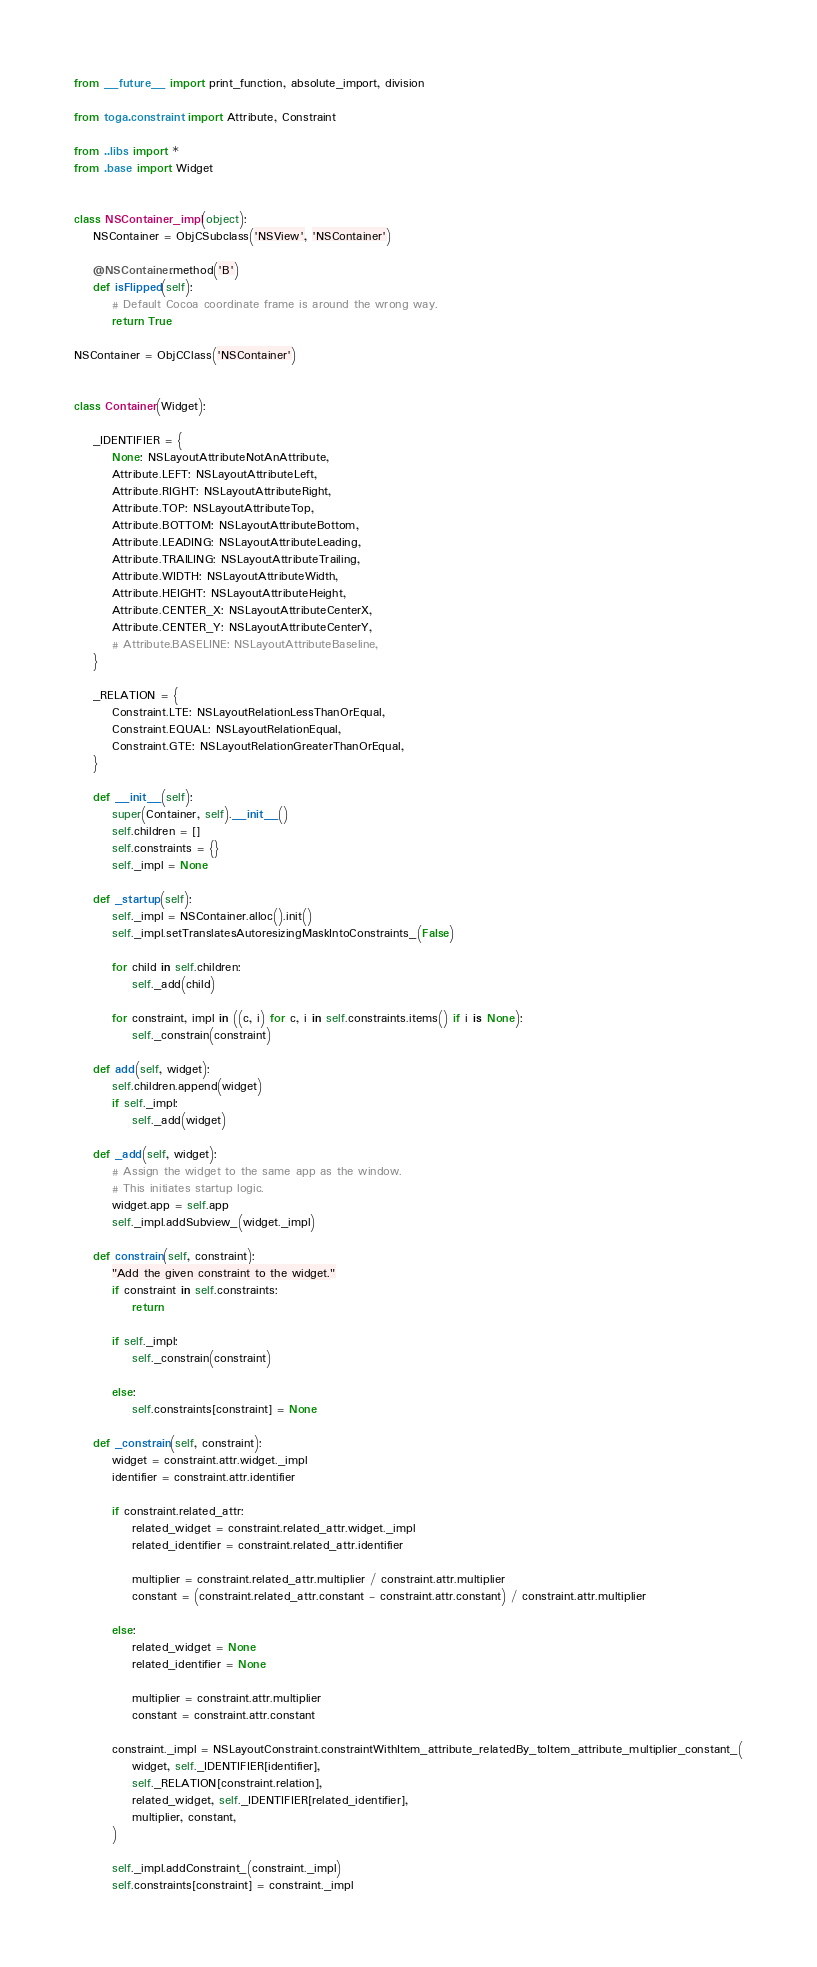Convert code to text. <code><loc_0><loc_0><loc_500><loc_500><_Python_>from __future__ import print_function, absolute_import, division

from toga.constraint import Attribute, Constraint

from ..libs import *
from .base import Widget


class NSContainer_impl(object):
    NSContainer = ObjCSubclass('NSView', 'NSContainer')

    @NSContainer.method('B')
    def isFlipped(self):
        # Default Cocoa coordinate frame is around the wrong way.
        return True

NSContainer = ObjCClass('NSContainer')


class Container(Widget):

    _IDENTIFIER = {
        None: NSLayoutAttributeNotAnAttribute,
        Attribute.LEFT: NSLayoutAttributeLeft,
        Attribute.RIGHT: NSLayoutAttributeRight,
        Attribute.TOP: NSLayoutAttributeTop,
        Attribute.BOTTOM: NSLayoutAttributeBottom,
        Attribute.LEADING: NSLayoutAttributeLeading,
        Attribute.TRAILING: NSLayoutAttributeTrailing,
        Attribute.WIDTH: NSLayoutAttributeWidth,
        Attribute.HEIGHT: NSLayoutAttributeHeight,
        Attribute.CENTER_X: NSLayoutAttributeCenterX,
        Attribute.CENTER_Y: NSLayoutAttributeCenterY,
        # Attribute.BASELINE: NSLayoutAttributeBaseline,
    }

    _RELATION = {
        Constraint.LTE: NSLayoutRelationLessThanOrEqual,
        Constraint.EQUAL: NSLayoutRelationEqual,
        Constraint.GTE: NSLayoutRelationGreaterThanOrEqual,
    }

    def __init__(self):
        super(Container, self).__init__()
        self.children = []
        self.constraints = {}
        self._impl = None

    def _startup(self):
        self._impl = NSContainer.alloc().init()
        self._impl.setTranslatesAutoresizingMaskIntoConstraints_(False)

        for child in self.children:
            self._add(child)

        for constraint, impl in ((c, i) for c, i in self.constraints.items() if i is None):
            self._constrain(constraint)

    def add(self, widget):
        self.children.append(widget)
        if self._impl:
            self._add(widget)

    def _add(self, widget):
        # Assign the widget to the same app as the window.
        # This initiates startup logic.
        widget.app = self.app
        self._impl.addSubview_(widget._impl)

    def constrain(self, constraint):
        "Add the given constraint to the widget."
        if constraint in self.constraints:
            return

        if self._impl:
            self._constrain(constraint)

        else:
            self.constraints[constraint] = None

    def _constrain(self, constraint):
        widget = constraint.attr.widget._impl
        identifier = constraint.attr.identifier

        if constraint.related_attr:
            related_widget = constraint.related_attr.widget._impl
            related_identifier = constraint.related_attr.identifier

            multiplier = constraint.related_attr.multiplier / constraint.attr.multiplier
            constant = (constraint.related_attr.constant - constraint.attr.constant) / constraint.attr.multiplier

        else:
            related_widget = None
            related_identifier = None

            multiplier = constraint.attr.multiplier
            constant = constraint.attr.constant

        constraint._impl = NSLayoutConstraint.constraintWithItem_attribute_relatedBy_toItem_attribute_multiplier_constant_(
            widget, self._IDENTIFIER[identifier],
            self._RELATION[constraint.relation],
            related_widget, self._IDENTIFIER[related_identifier],
            multiplier, constant,
        )

        self._impl.addConstraint_(constraint._impl)
        self.constraints[constraint] = constraint._impl
</code> 